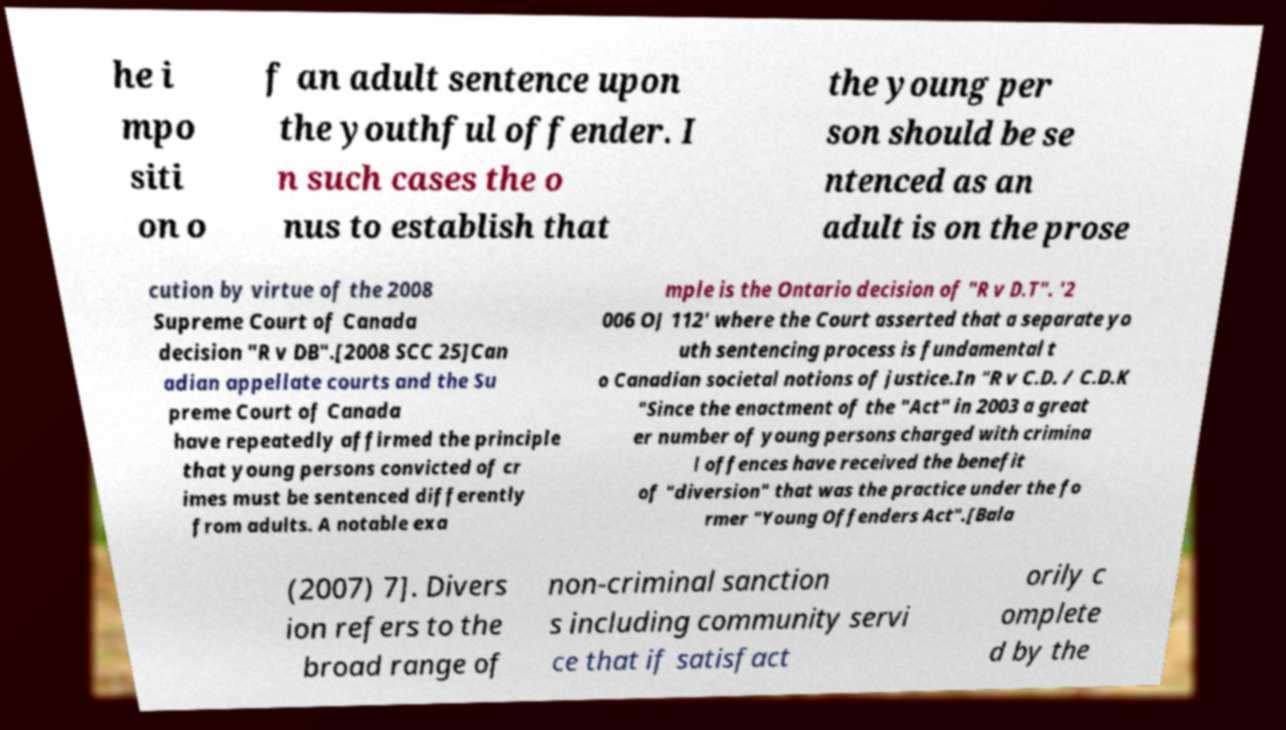For documentation purposes, I need the text within this image transcribed. Could you provide that? he i mpo siti on o f an adult sentence upon the youthful offender. I n such cases the o nus to establish that the young per son should be se ntenced as an adult is on the prose cution by virtue of the 2008 Supreme Court of Canada decision "R v DB".[2008 SCC 25]Can adian appellate courts and the Su preme Court of Canada have repeatedly affirmed the principle that young persons convicted of cr imes must be sentenced differently from adults. A notable exa mple is the Ontario decision of "R v D.T". '2 006 OJ 112' where the Court asserted that a separate yo uth sentencing process is fundamental t o Canadian societal notions of justice.In "R v C.D. / C.D.K "Since the enactment of the "Act" in 2003 a great er number of young persons charged with crimina l offences have received the benefit of "diversion" that was the practice under the fo rmer "Young Offenders Act".[Bala (2007) 7]. Divers ion refers to the broad range of non-criminal sanction s including community servi ce that if satisfact orily c omplete d by the 